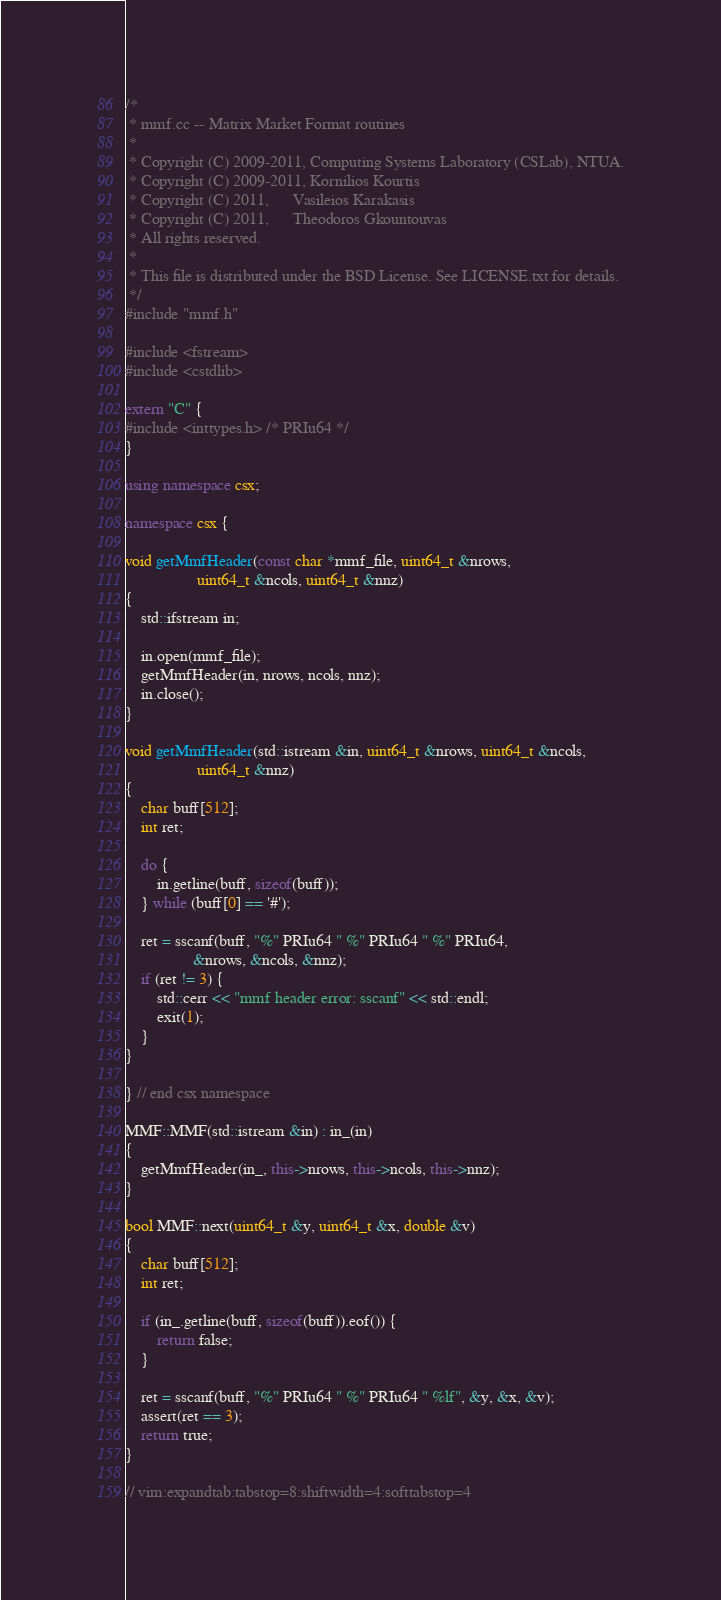Convert code to text. <code><loc_0><loc_0><loc_500><loc_500><_C++_>/*
 * mmf.cc -- Matrix Market Format routines
 *
 * Copyright (C) 2009-2011, Computing Systems Laboratory (CSLab), NTUA.
 * Copyright (C) 2009-2011, Kornilios Kourtis
 * Copyright (C) 2011,      Vasileios Karakasis
 * Copyright (C) 2011,      Theodoros Gkountouvas
 * All rights reserved.
 *
 * This file is distributed under the BSD License. See LICENSE.txt for details.
 */
#include "mmf.h"

#include <fstream>
#include <cstdlib>

extern "C" {
#include <inttypes.h> /* PRIu64 */
}

using namespace csx;

namespace csx {

void getMmfHeader(const char *mmf_file, uint64_t &nrows,
                  uint64_t &ncols, uint64_t &nnz)
{
    std::ifstream in;

    in.open(mmf_file);
    getMmfHeader(in, nrows, ncols, nnz);
    in.close();
}

void getMmfHeader(std::istream &in, uint64_t &nrows, uint64_t &ncols,
                  uint64_t &nnz)
{
    char buff[512];
    int ret;

    do {
        in.getline(buff, sizeof(buff));
    } while (buff[0] == '#');

    ret = sscanf(buff, "%" PRIu64 " %" PRIu64 " %" PRIu64,
                 &nrows, &ncols, &nnz);
    if (ret != 3) {
        std::cerr << "mmf header error: sscanf" << std::endl;
        exit(1);
    }
}

} // end csx namespace

MMF::MMF(std::istream &in) : in_(in)
{
    getMmfHeader(in_, this->nrows, this->ncols, this->nnz);
}

bool MMF::next(uint64_t &y, uint64_t &x, double &v)
{
    char buff[512];
    int ret;

    if (in_.getline(buff, sizeof(buff)).eof()) {
        return false;
    }

    ret = sscanf(buff, "%" PRIu64 " %" PRIu64 " %lf", &y, &x, &v);
    assert(ret == 3);
    return true;
}

// vim:expandtab:tabstop=8:shiftwidth=4:softtabstop=4
</code> 